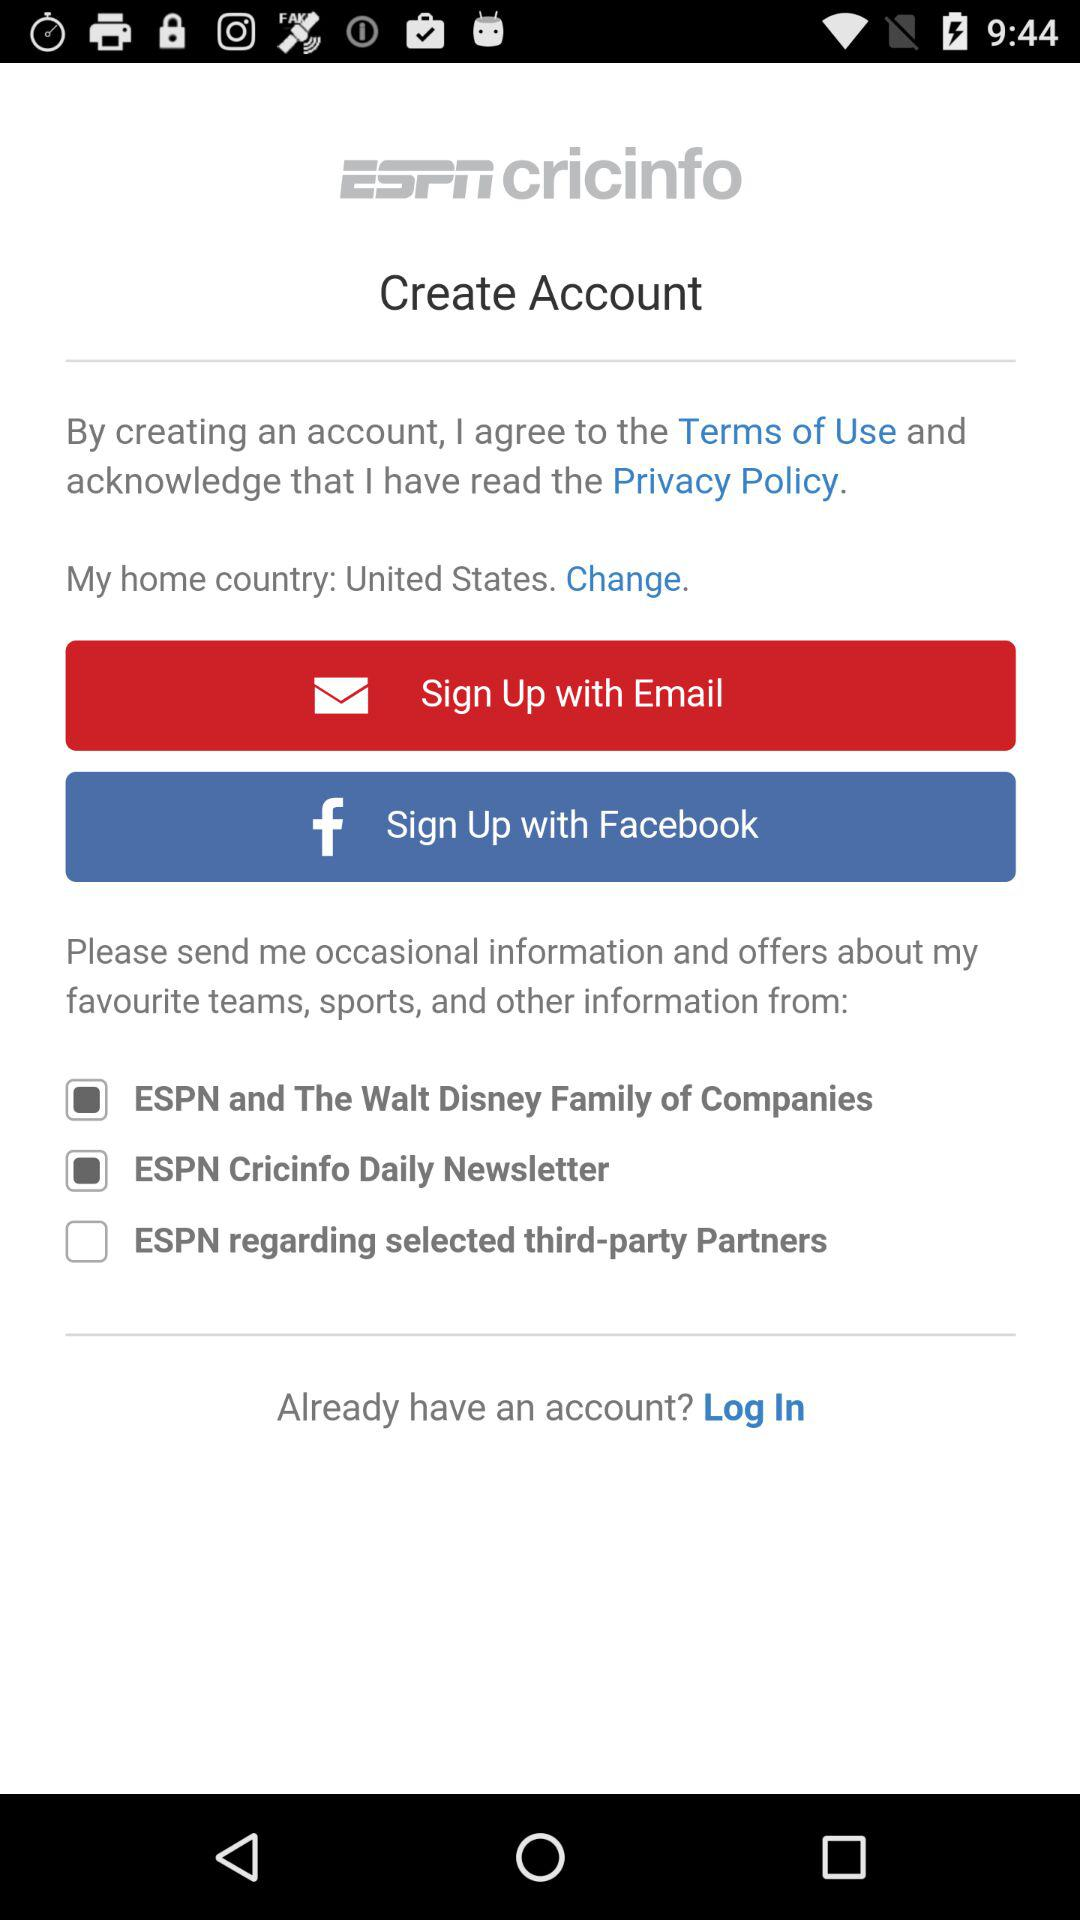How many check boxes are there to select which information and offers to receive?
Answer the question using a single word or phrase. 3 